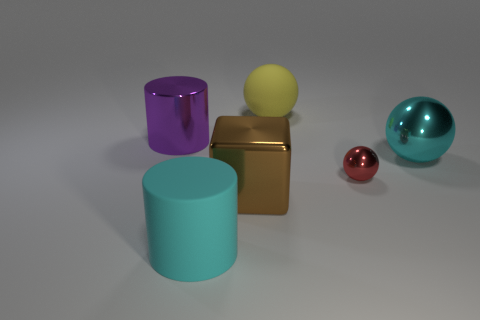Are there any other things that are made of the same material as the yellow thing?
Provide a short and direct response. Yes. Is the number of big brown metal objects in front of the shiny cube greater than the number of tiny things?
Keep it short and to the point. No. Are there any red metallic objects in front of the large shiny thing that is in front of the big thing to the right of the yellow thing?
Provide a short and direct response. No. There is a big block; are there any tiny metal balls to the left of it?
Provide a succinct answer. No. How many small things are the same color as the big rubber cylinder?
Provide a short and direct response. 0. What is the size of the cyan cylinder that is the same material as the large yellow sphere?
Provide a succinct answer. Large. There is a object that is behind the cylinder that is behind the big cylinder in front of the small red ball; what size is it?
Offer a very short reply. Large. How big is the cyan object that is left of the large brown block?
Your answer should be compact. Large. How many gray objects are either metal spheres or large cubes?
Your response must be concise. 0. Are there any brown metallic blocks of the same size as the cyan cylinder?
Provide a succinct answer. Yes. 